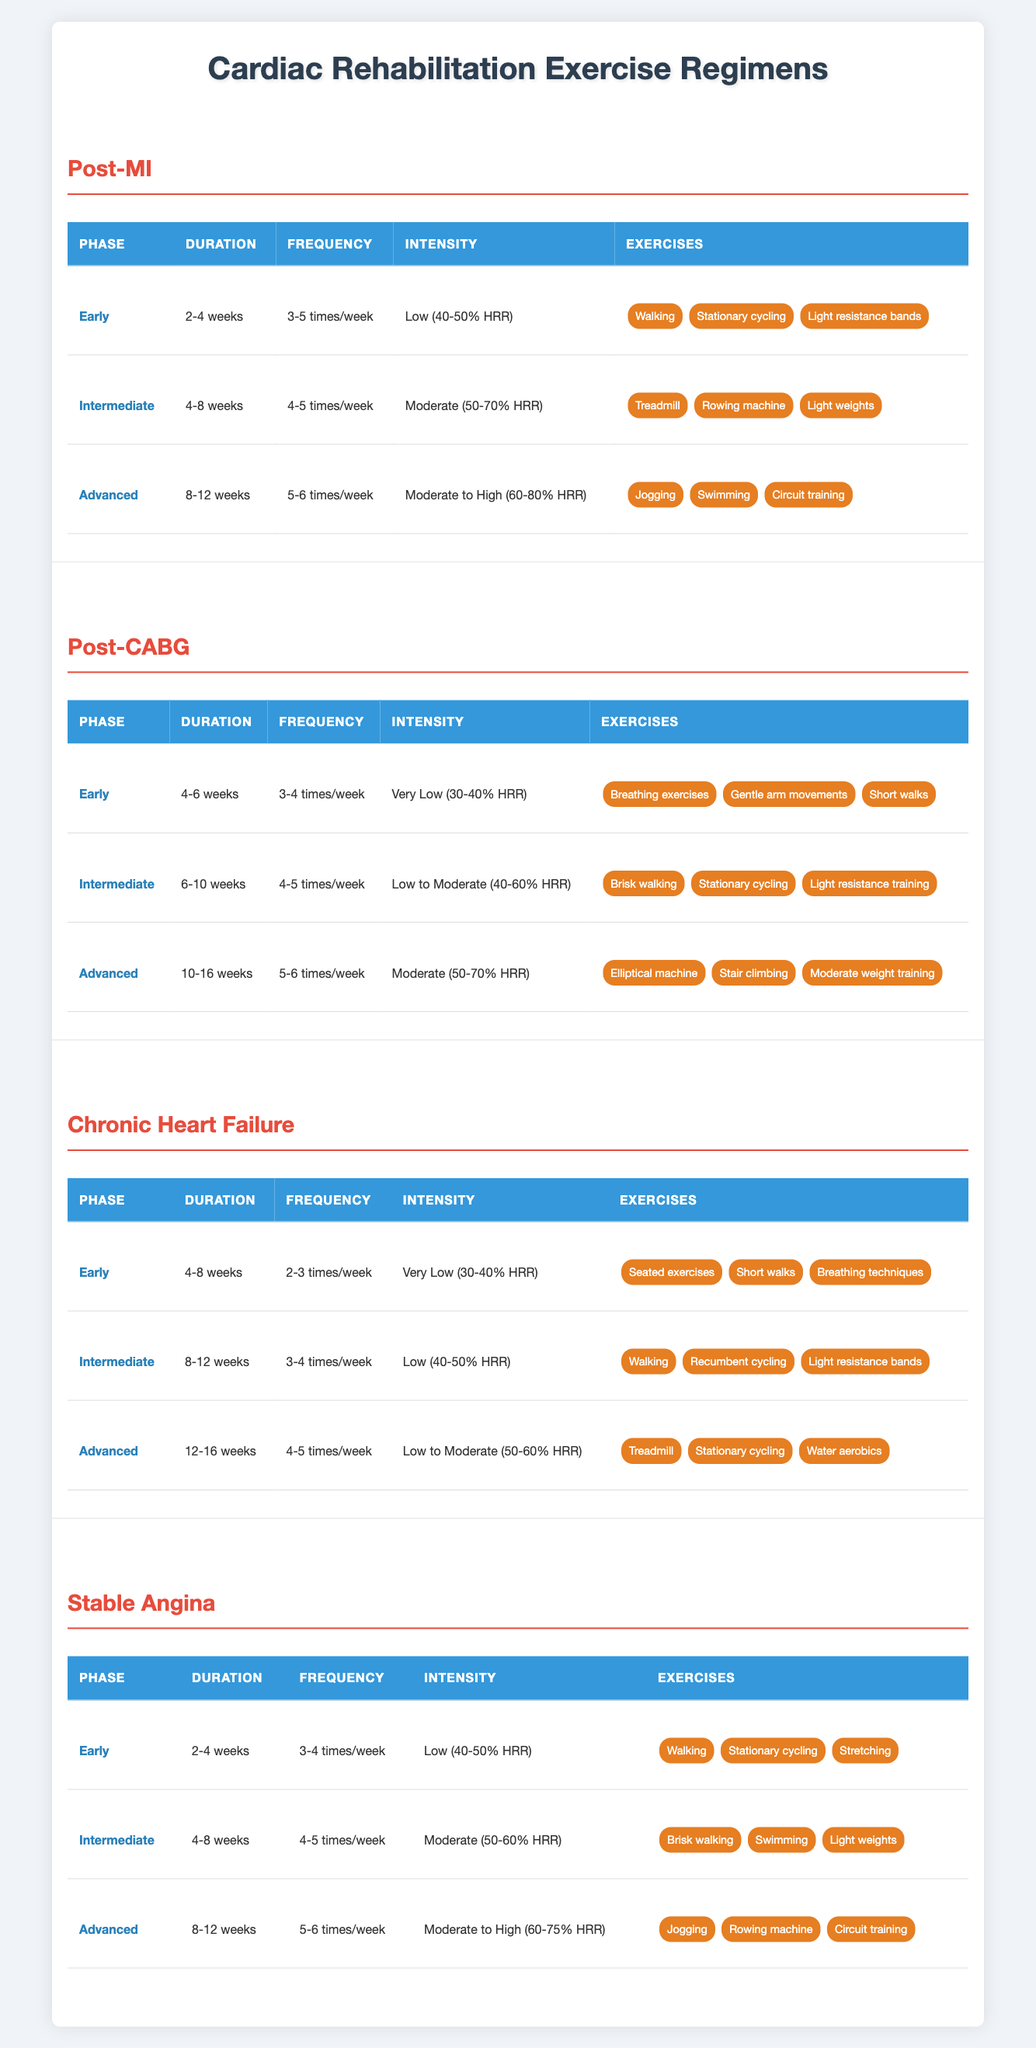What is the exercise frequency for the Advanced phase of Post-MI recovery? In the "Post-MI" category, under "Advanced" phase, the frequency is listed as "5-6 times/week."
Answer: 5-6 times/week What types of exercises are recommended during the Early phase for Chronic Heart Failure patients? According to the table, the "Early" phase for Chronic Heart Failure patients includes exercises like "Seated exercises," "Short walks," and "Breathing techniques."
Answer: Seated exercises, Short walks, Breathing techniques Is the intensity for the Intermediate phase of Post-CABG higher than that of the Early phase? The "Intermediate" phase intensity for Post-CABG is "Low to Moderate (40-60% HRR)" while the "Early" phase intensity is "Very Low (30-40% HRR). Thus, it is yes, the intensity in the Intermediate phase is higher.
Answer: Yes What is the average duration for the Advanced phase across all patient categories? The durations for the Advanced phase are 12 weeks (Chronic Heart Failure), 12 weeks (Post-MI), 16 weeks (Post-CABG), and 12 weeks (Stable Angina). Summing these durations gives 12 + 12 + 16 + 12 = 52 weeks. Dividing by 4 (the number of patient categories), the average is 52/4 = 13 weeks.
Answer: 13 weeks Are there any exercises listed for the Early phase of Stable Angina? Yes, the "Early" phase for Stable Angina includes exercises such as "Walking," "Stationary cycling," and "Stretching."
Answer: Yes Which patient category has the longest duration for the Advanced phase? In the "Advanced" phase, the duration for Post-CABG is "10-16 weeks," which is longer than the 8-12 weeks of Post-MI, 12-16 weeks of Chronic Heart Failure, and 8-12 weeks of Stable Angina. Comparing these, Post-CABG has the longest duration.
Answer: Post-CABG How many different exercises are recommended for the Intermediate phase of Chronic Heart Failure? The "Intermediate" phase for Chronic Heart Failure recommends "Walking," "Recumbent cycling," and "Light resistance bands," totaling three different exercises.
Answer: 3 What exercises are included in the Advanced phase for patients with Stable Angina? In the Advanced phase of Stable Angina, patients are recommended to perform "Jogging," "Rowing machine," and "Circuit training."
Answer: Jogging, Rowing machine, Circuit training 